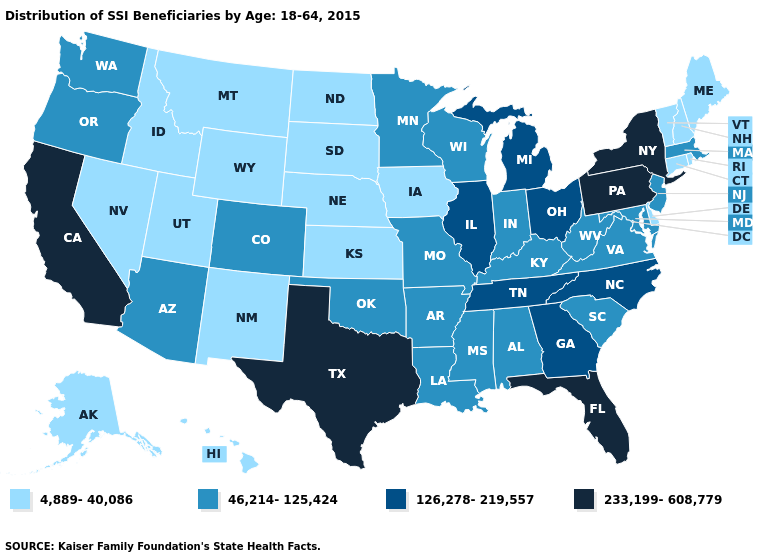Name the states that have a value in the range 4,889-40,086?
Answer briefly. Alaska, Connecticut, Delaware, Hawaii, Idaho, Iowa, Kansas, Maine, Montana, Nebraska, Nevada, New Hampshire, New Mexico, North Dakota, Rhode Island, South Dakota, Utah, Vermont, Wyoming. What is the value of Kentucky?
Write a very short answer. 46,214-125,424. What is the value of Maine?
Keep it brief. 4,889-40,086. What is the value of Arkansas?
Concise answer only. 46,214-125,424. Which states hav the highest value in the MidWest?
Answer briefly. Illinois, Michigan, Ohio. Which states have the highest value in the USA?
Keep it brief. California, Florida, New York, Pennsylvania, Texas. How many symbols are there in the legend?
Short answer required. 4. What is the value of Iowa?
Write a very short answer. 4,889-40,086. Name the states that have a value in the range 233,199-608,779?
Give a very brief answer. California, Florida, New York, Pennsylvania, Texas. Name the states that have a value in the range 4,889-40,086?
Short answer required. Alaska, Connecticut, Delaware, Hawaii, Idaho, Iowa, Kansas, Maine, Montana, Nebraska, Nevada, New Hampshire, New Mexico, North Dakota, Rhode Island, South Dakota, Utah, Vermont, Wyoming. Among the states that border Utah , which have the highest value?
Give a very brief answer. Arizona, Colorado. Name the states that have a value in the range 4,889-40,086?
Concise answer only. Alaska, Connecticut, Delaware, Hawaii, Idaho, Iowa, Kansas, Maine, Montana, Nebraska, Nevada, New Hampshire, New Mexico, North Dakota, Rhode Island, South Dakota, Utah, Vermont, Wyoming. Does Nebraska have the highest value in the MidWest?
Quick response, please. No. Name the states that have a value in the range 233,199-608,779?
Keep it brief. California, Florida, New York, Pennsylvania, Texas. What is the highest value in states that border Colorado?
Be succinct. 46,214-125,424. 